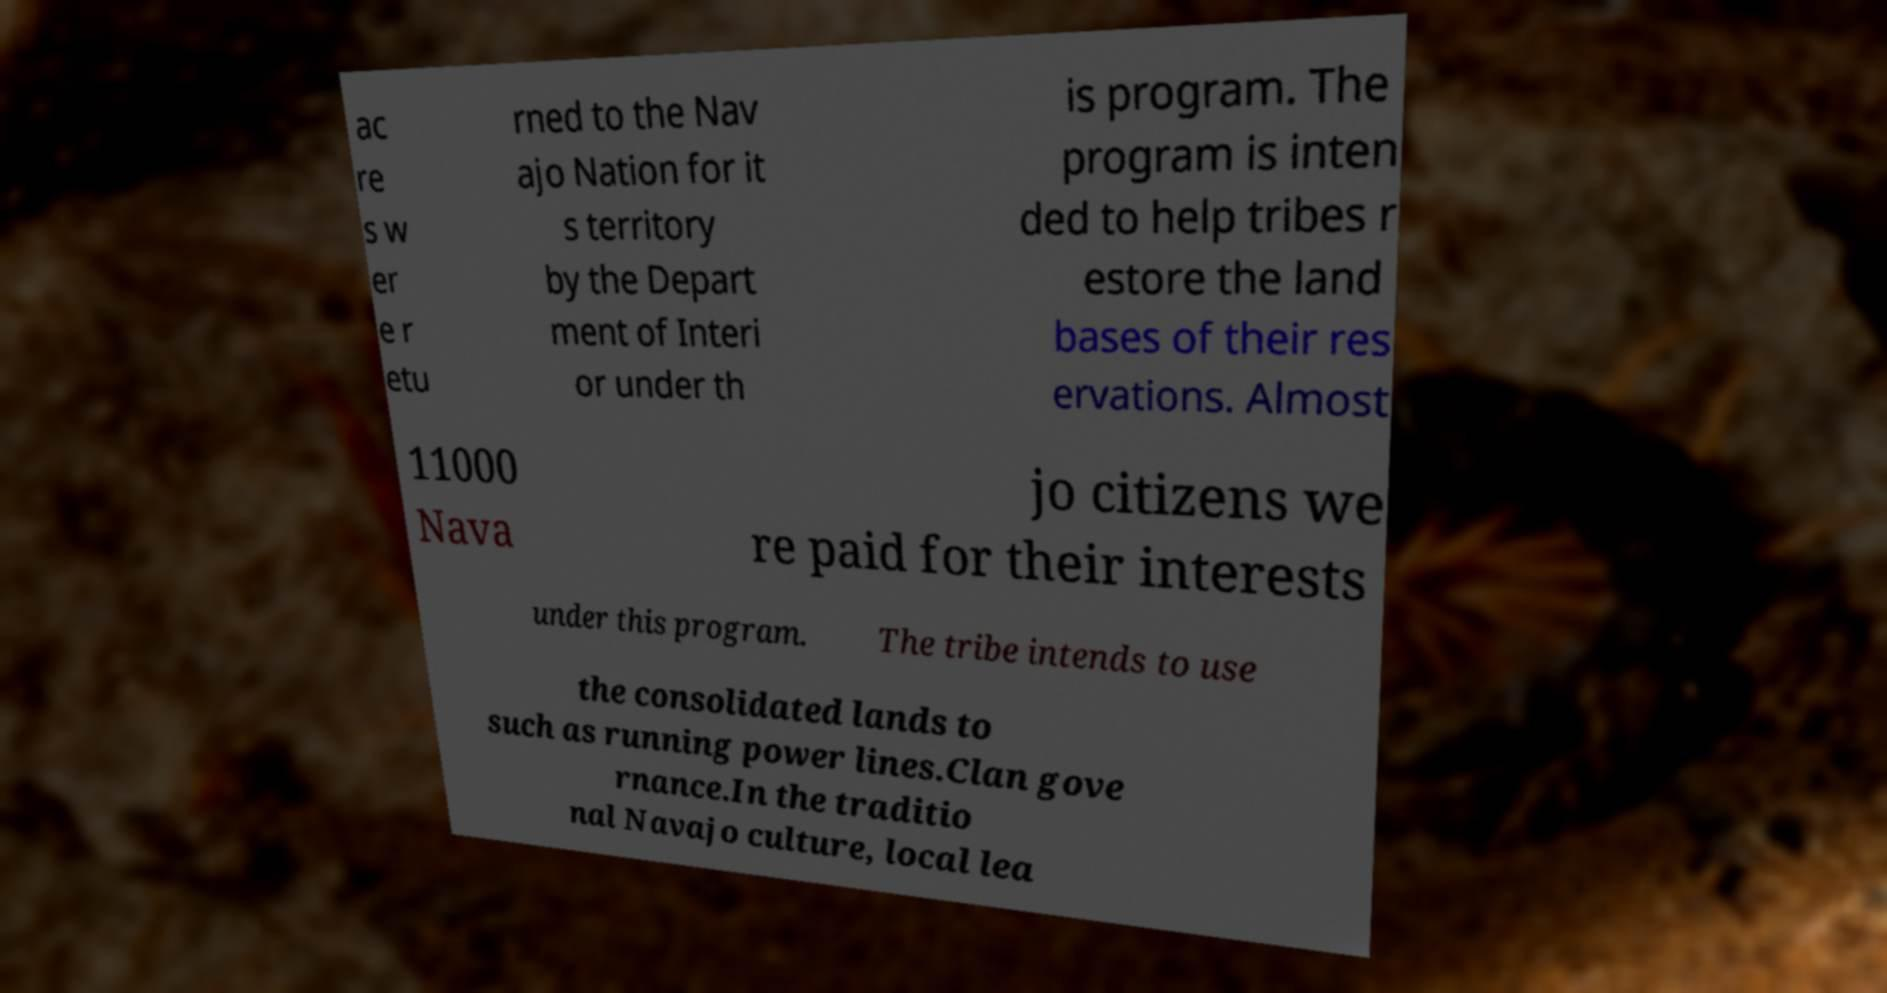Can you read and provide the text displayed in the image?This photo seems to have some interesting text. Can you extract and type it out for me? ac re s w er e r etu rned to the Nav ajo Nation for it s territory by the Depart ment of Interi or under th is program. The program is inten ded to help tribes r estore the land bases of their res ervations. Almost 11000 Nava jo citizens we re paid for their interests under this program. The tribe intends to use the consolidated lands to such as running power lines.Clan gove rnance.In the traditio nal Navajo culture, local lea 